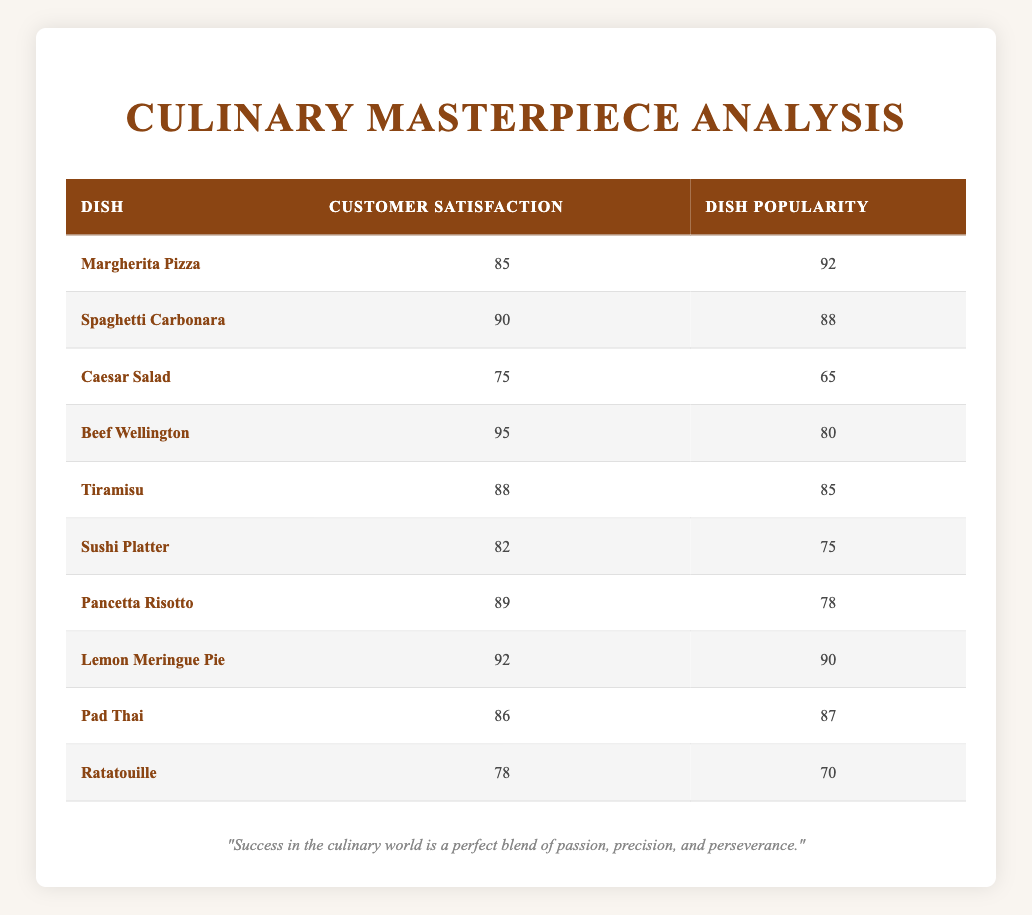What is the customer satisfaction score for Tiramisu? The table lists Tiramisu with a customer satisfaction score of 88.
Answer: 88 Which dish has the highest dish popularity score? Looking at the table, Margherita Pizza has the highest dish popularity score of 92.
Answer: Margherita Pizza What is the average customer satisfaction score of the dishes listed? To find the average, sum all customer satisfaction scores: 85 + 90 + 75 + 95 + 88 + 82 + 89 + 92 + 86 + 78 =  900. There are 10 dishes, so the average is 900 / 10 = 90.
Answer: 90 Is the customer satisfaction score for Beef Wellington higher than its dish popularity score? The customer satisfaction score for Beef Wellington is 95 and the dish popularity score is 80. Since 95 is greater than 80, the answer is yes.
Answer: Yes What is the satisfaction score of the dish that has the lowest popularity score? The dish with the lowest popularity score is Caesar Salad, which has a customer satisfaction score of 75.
Answer: 75 